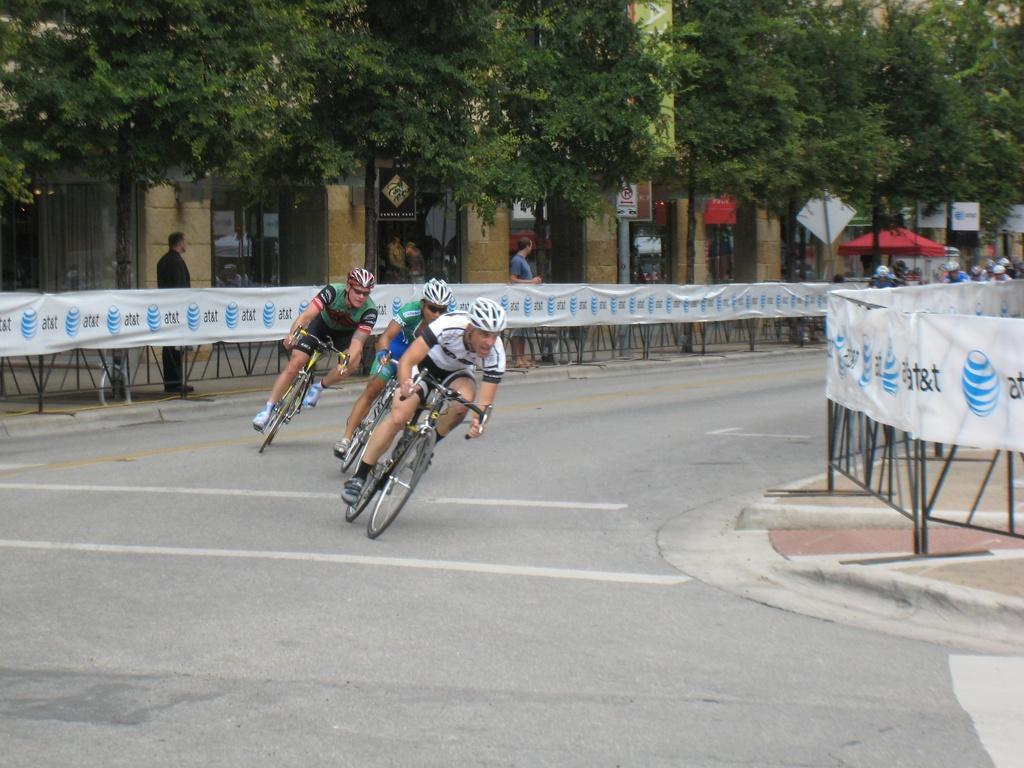In one or two sentences, can you explain what this image depicts? There are three persons riding on bicycles and in the background we can see a fence,persons,trees. 